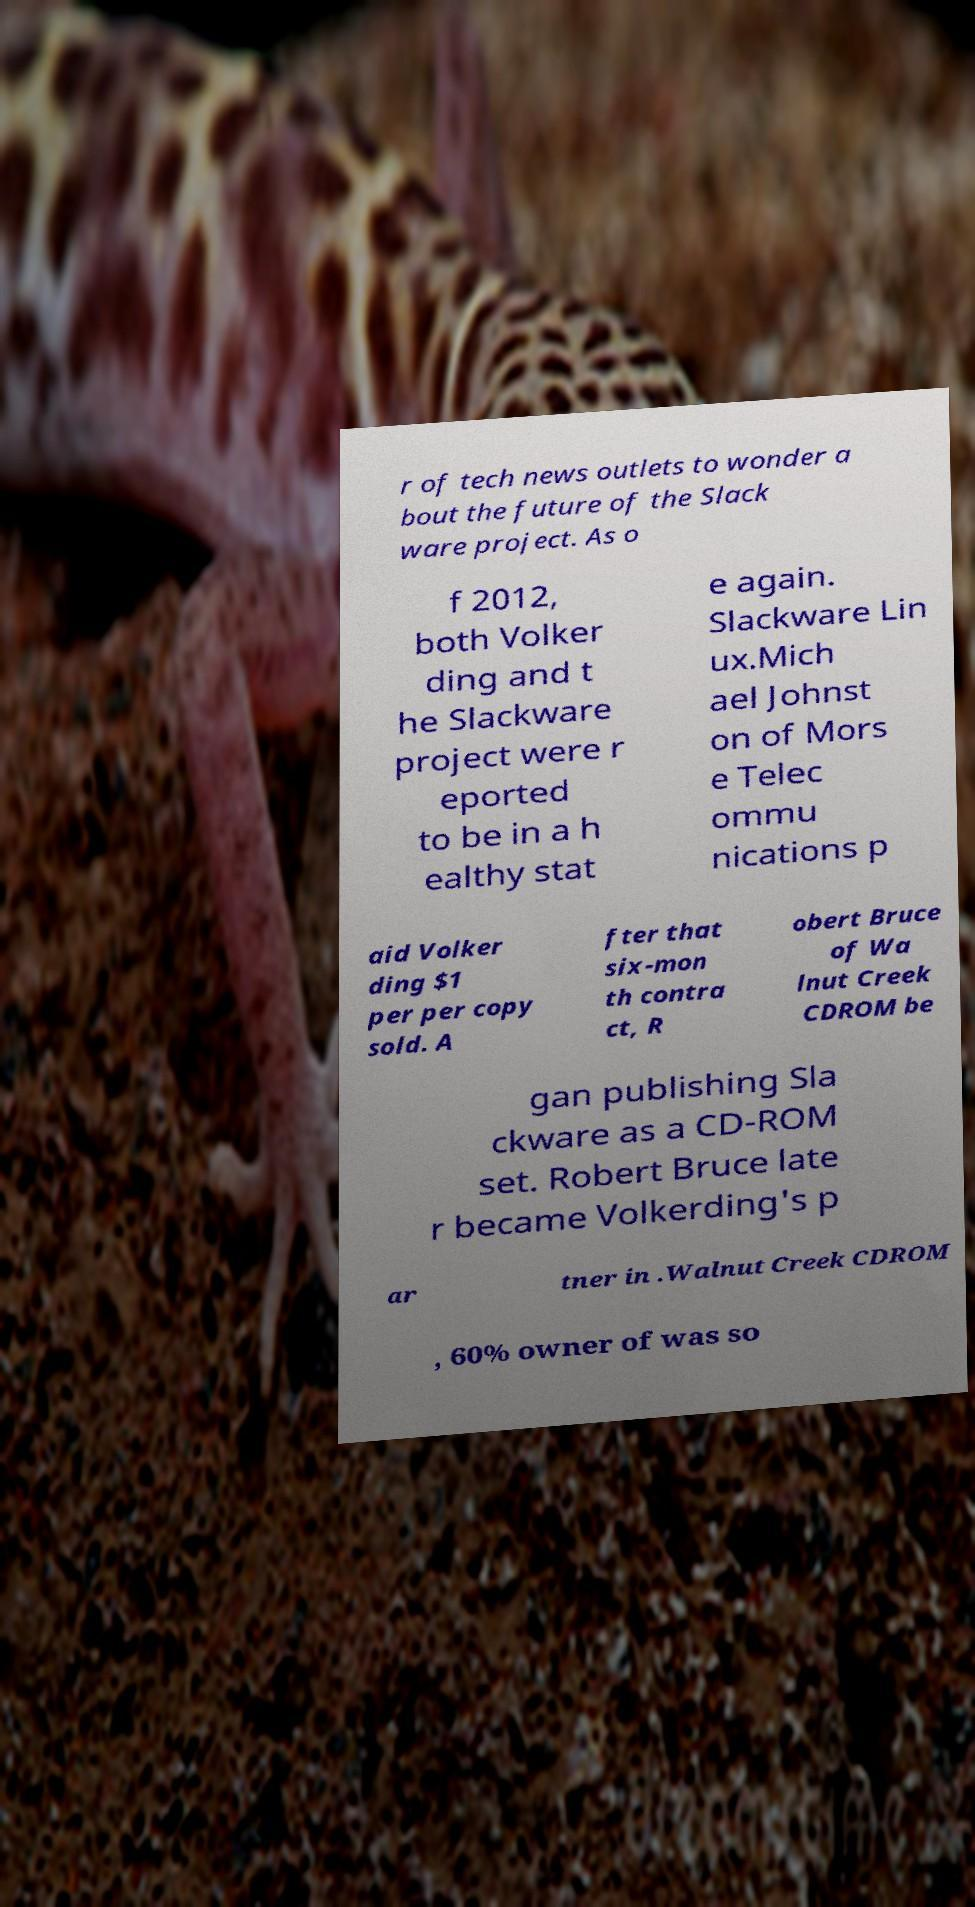Can you accurately transcribe the text from the provided image for me? r of tech news outlets to wonder a bout the future of the Slack ware project. As o f 2012, both Volker ding and t he Slackware project were r eported to be in a h ealthy stat e again. Slackware Lin ux.Mich ael Johnst on of Mors e Telec ommu nications p aid Volker ding $1 per per copy sold. A fter that six-mon th contra ct, R obert Bruce of Wa lnut Creek CDROM be gan publishing Sla ckware as a CD-ROM set. Robert Bruce late r became Volkerding's p ar tner in .Walnut Creek CDROM , 60% owner of was so 